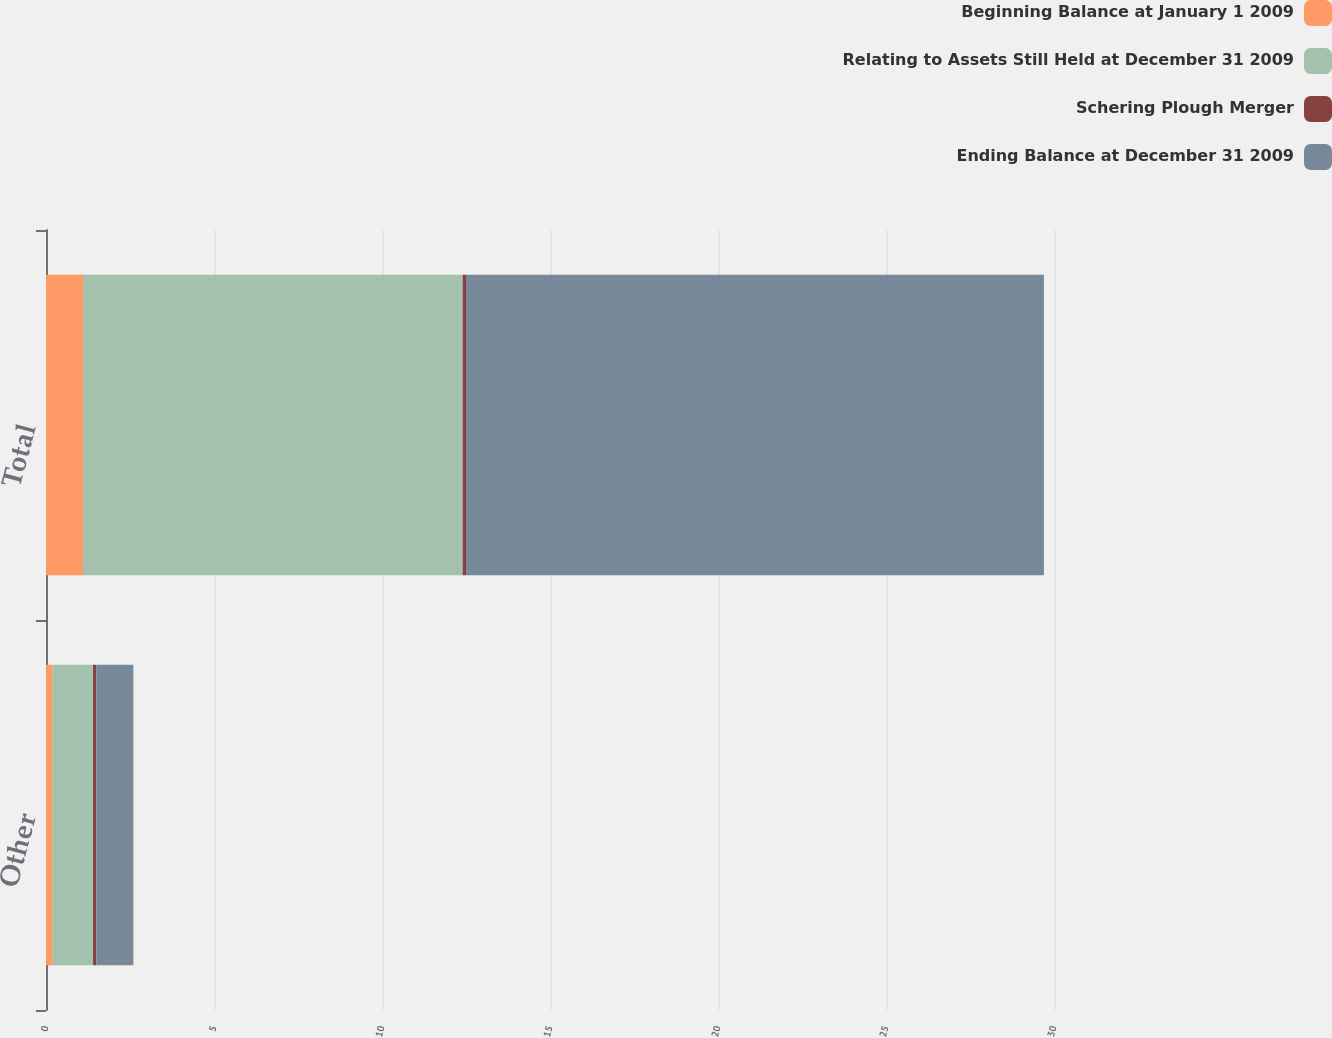Convert chart. <chart><loc_0><loc_0><loc_500><loc_500><stacked_bar_chart><ecel><fcel>Other<fcel>Total<nl><fcel>Beginning Balance at January 1 2009<fcel>0.2<fcel>1.1<nl><fcel>Relating to Assets Still Held at December 31 2009<fcel>1.2<fcel>11.3<nl><fcel>Schering Plough Merger<fcel>0.1<fcel>0.1<nl><fcel>Ending Balance at December 31 2009<fcel>1.1<fcel>17.2<nl></chart> 